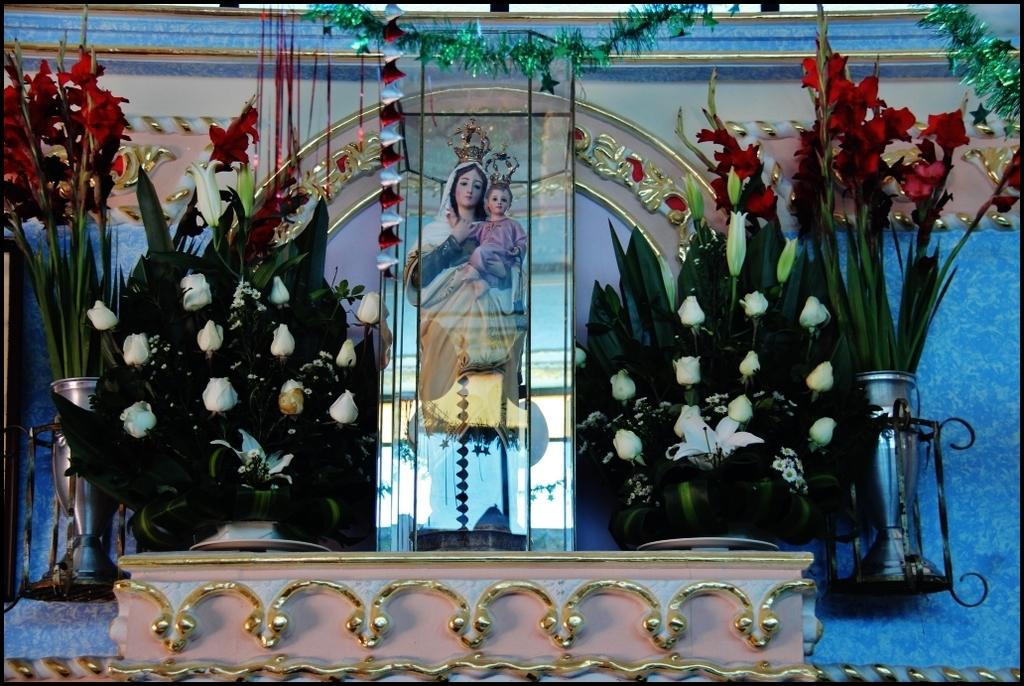What is the main subject of the image? There are many flowers in the image. What other object can be seen in the image besides the flowers? There is a sculpture of a woman holding a baby in the image. How is the sculpture displayed in the image? The sculpture is kept inside a glass box. What type of tub can be seen in the image? There is no tub present in the image. 